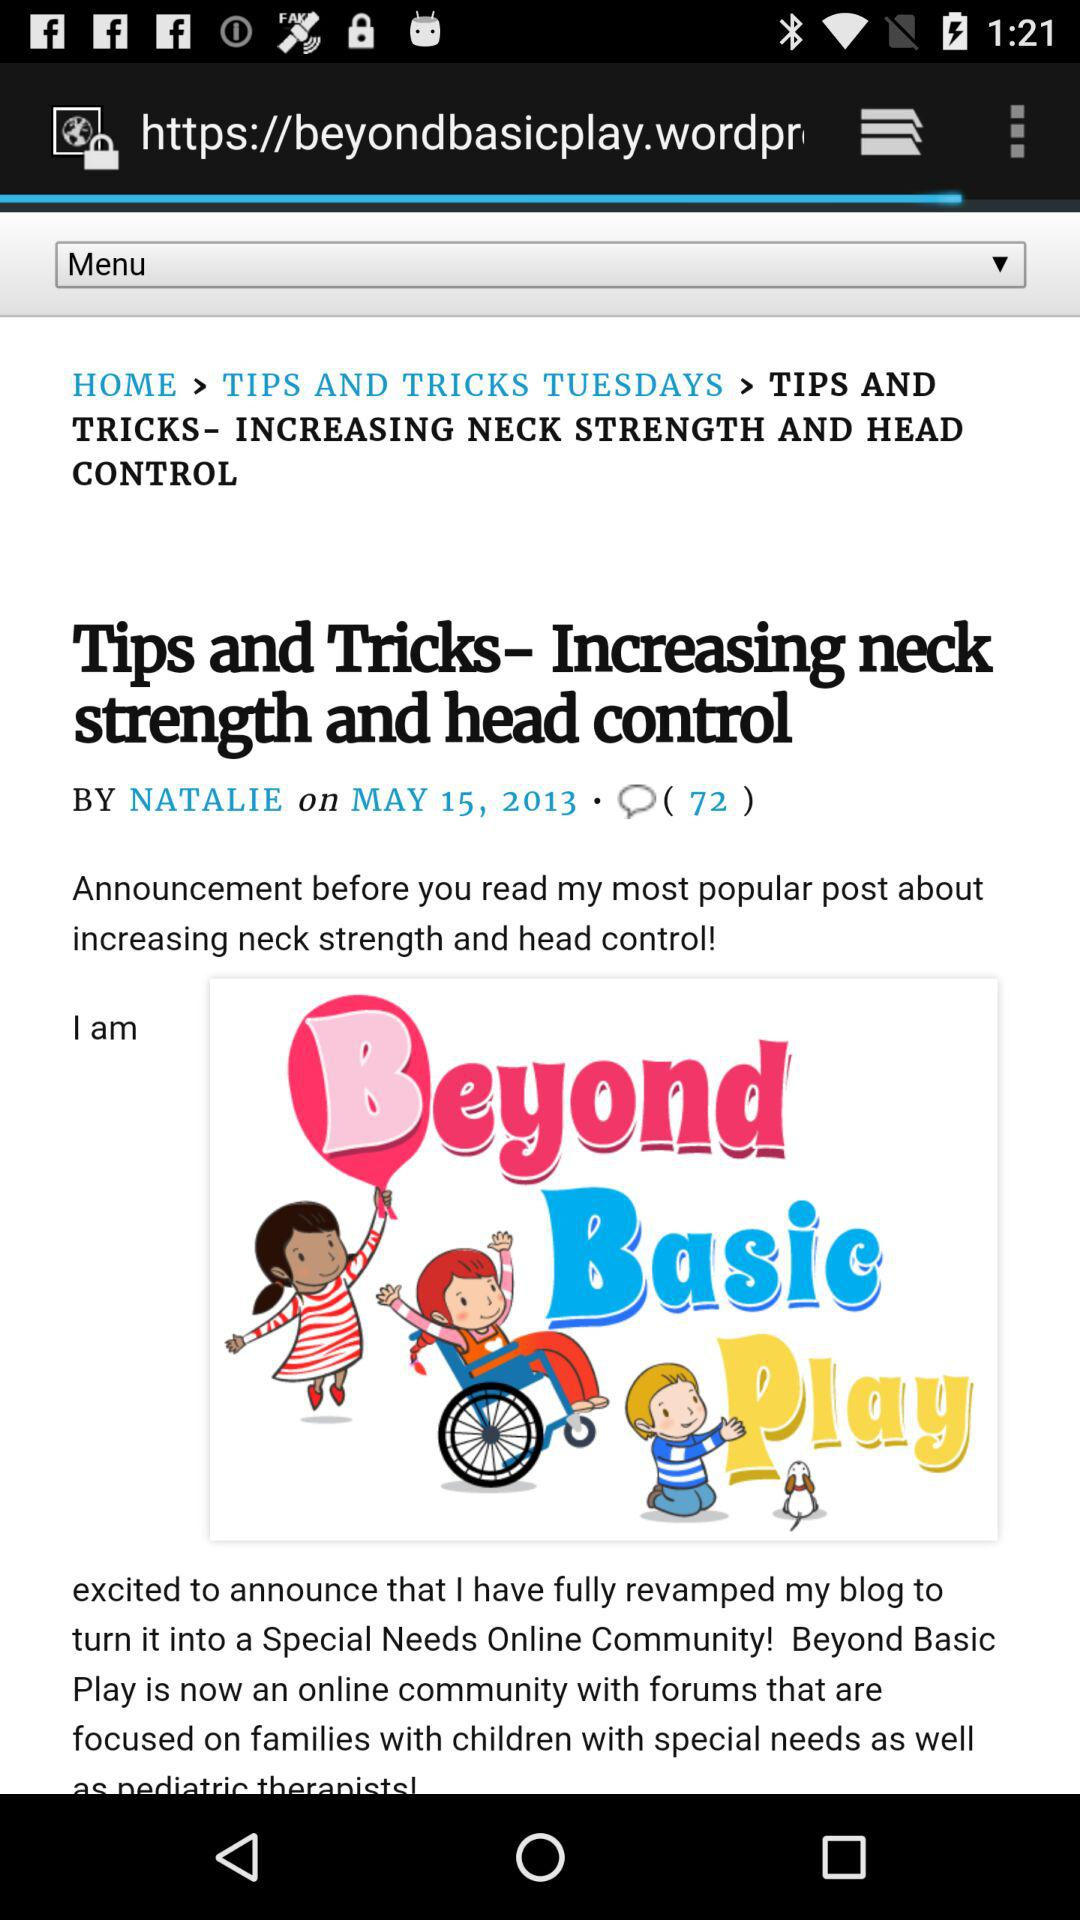Who is the writer? The writer is Natalie. 